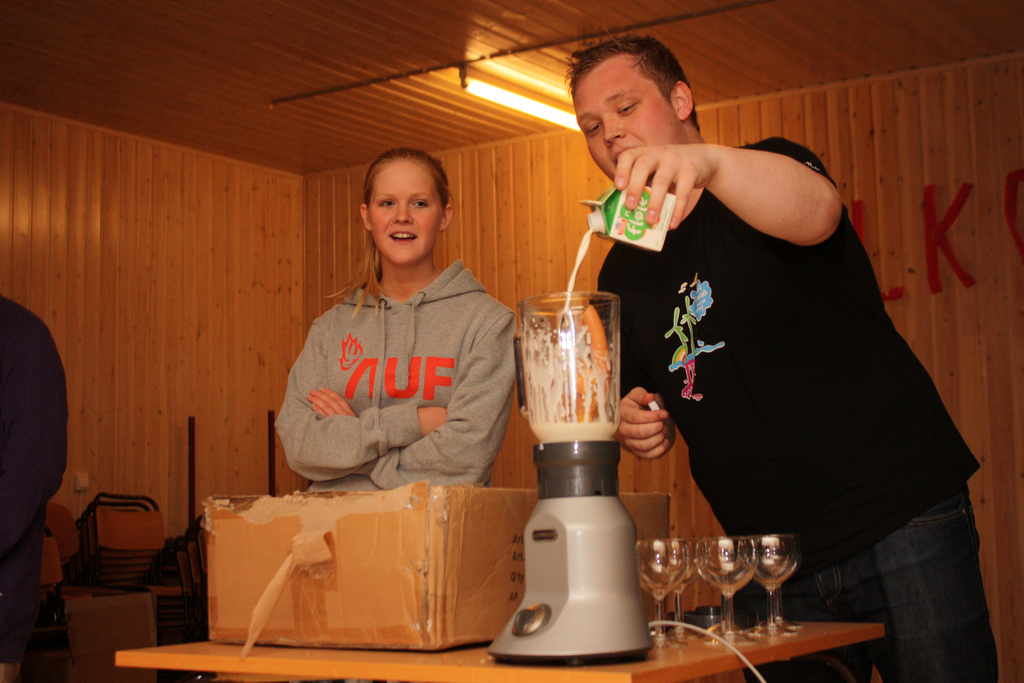Describe the setting and mood in the room. The setting is a cozy, casual environment with wood paneling adding warmth to the room. The mood seems informal and relaxed, possibly during a friendly gathering or cooking session. 